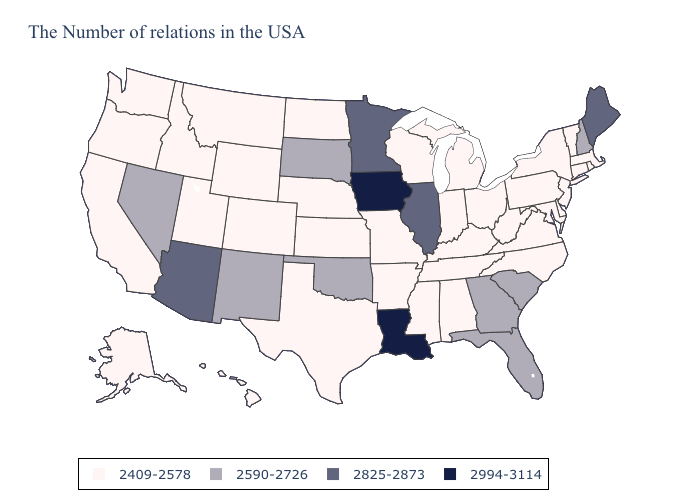Name the states that have a value in the range 2825-2873?
Write a very short answer. Maine, Illinois, Minnesota, Arizona. Which states hav the highest value in the Northeast?
Concise answer only. Maine. Does New York have the same value as Illinois?
Answer briefly. No. Name the states that have a value in the range 2994-3114?
Write a very short answer. Louisiana, Iowa. Does South Dakota have a higher value than Mississippi?
Keep it brief. Yes. What is the lowest value in states that border Ohio?
Concise answer only. 2409-2578. Does New York have the highest value in the Northeast?
Answer briefly. No. What is the value of Oklahoma?
Be succinct. 2590-2726. What is the lowest value in states that border Nebraska?
Write a very short answer. 2409-2578. What is the value of Wisconsin?
Be succinct. 2409-2578. Name the states that have a value in the range 2409-2578?
Answer briefly. Massachusetts, Rhode Island, Vermont, Connecticut, New York, New Jersey, Delaware, Maryland, Pennsylvania, Virginia, North Carolina, West Virginia, Ohio, Michigan, Kentucky, Indiana, Alabama, Tennessee, Wisconsin, Mississippi, Missouri, Arkansas, Kansas, Nebraska, Texas, North Dakota, Wyoming, Colorado, Utah, Montana, Idaho, California, Washington, Oregon, Alaska, Hawaii. What is the value of New Mexico?
Give a very brief answer. 2590-2726. Which states have the lowest value in the USA?
Write a very short answer. Massachusetts, Rhode Island, Vermont, Connecticut, New York, New Jersey, Delaware, Maryland, Pennsylvania, Virginia, North Carolina, West Virginia, Ohio, Michigan, Kentucky, Indiana, Alabama, Tennessee, Wisconsin, Mississippi, Missouri, Arkansas, Kansas, Nebraska, Texas, North Dakota, Wyoming, Colorado, Utah, Montana, Idaho, California, Washington, Oregon, Alaska, Hawaii. What is the lowest value in states that border Illinois?
Give a very brief answer. 2409-2578. Does Mississippi have a lower value than Rhode Island?
Short answer required. No. 